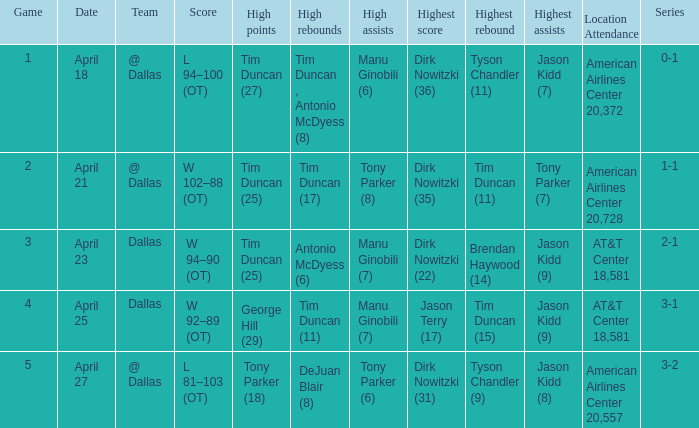When george hill (29) has the highest amount of points what is the date? April 25. 